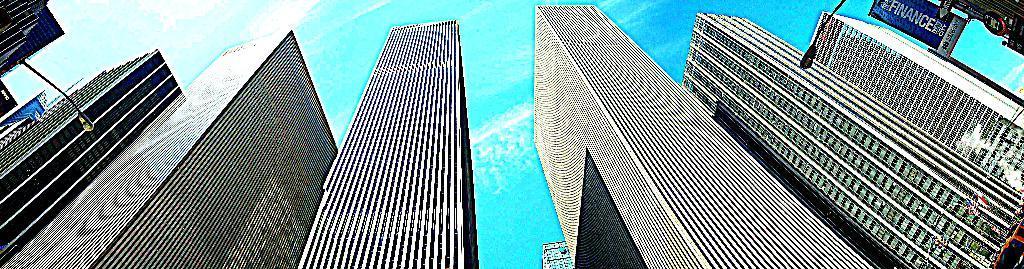How would you summarize this image in a sentence or two? There are many buildings. On the sides there are street lights. On the right corner there are some banners. In the background there is sky. 